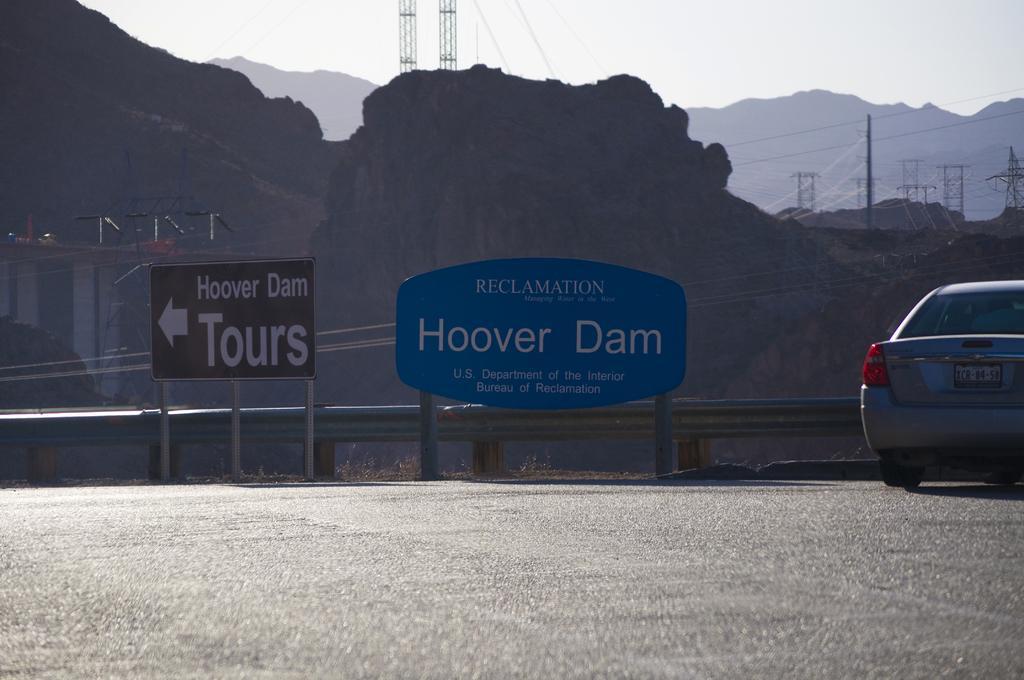Please provide a concise description of this image. In the image there is a car on the left side of road with label boards in the middle and behind there are hills with electric poles in the back and above its sky. 